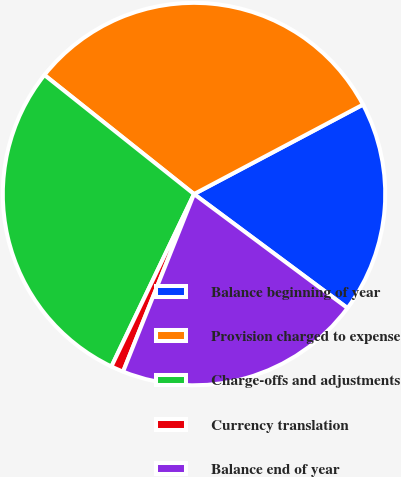<chart> <loc_0><loc_0><loc_500><loc_500><pie_chart><fcel>Balance beginning of year<fcel>Provision charged to expense<fcel>Charge-offs and adjustments<fcel>Currency translation<fcel>Balance end of year<nl><fcel>17.92%<fcel>31.55%<fcel>28.59%<fcel>1.06%<fcel>20.88%<nl></chart> 